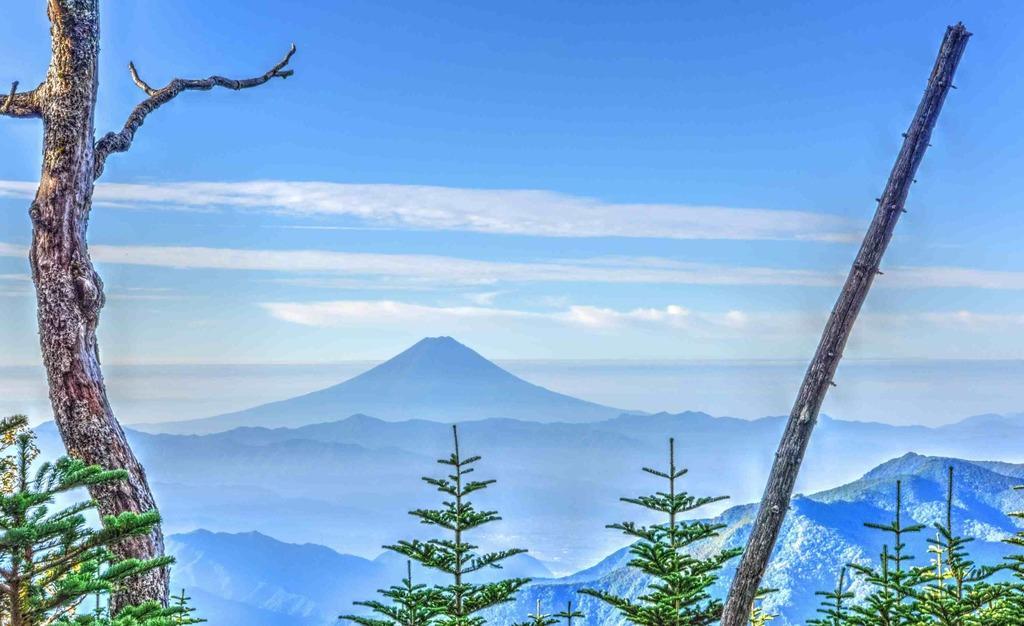How would you summarize this image in a sentence or two? In this image I can see few trees which are green, black and ash in color. In the background I can see few mountains and the sky. 